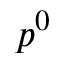Convert formula to latex. <formula><loc_0><loc_0><loc_500><loc_500>p ^ { 0 }</formula> 